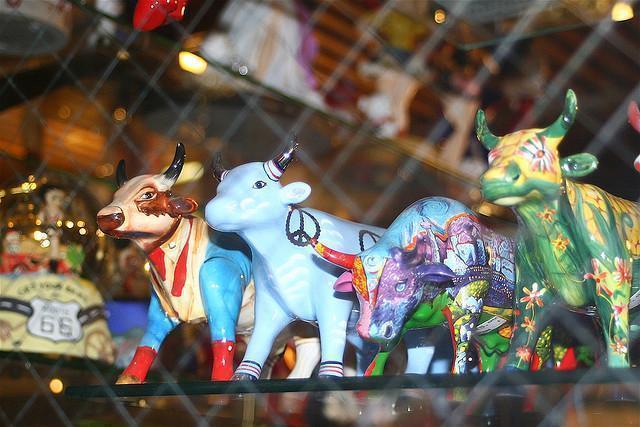Who wrote the famous song inspired by this highway?
Make your selection from the four choices given to correctly answer the question.
Options: Michael jackson, elvis presley, bobby troup, dean martin. Bobby troup. 